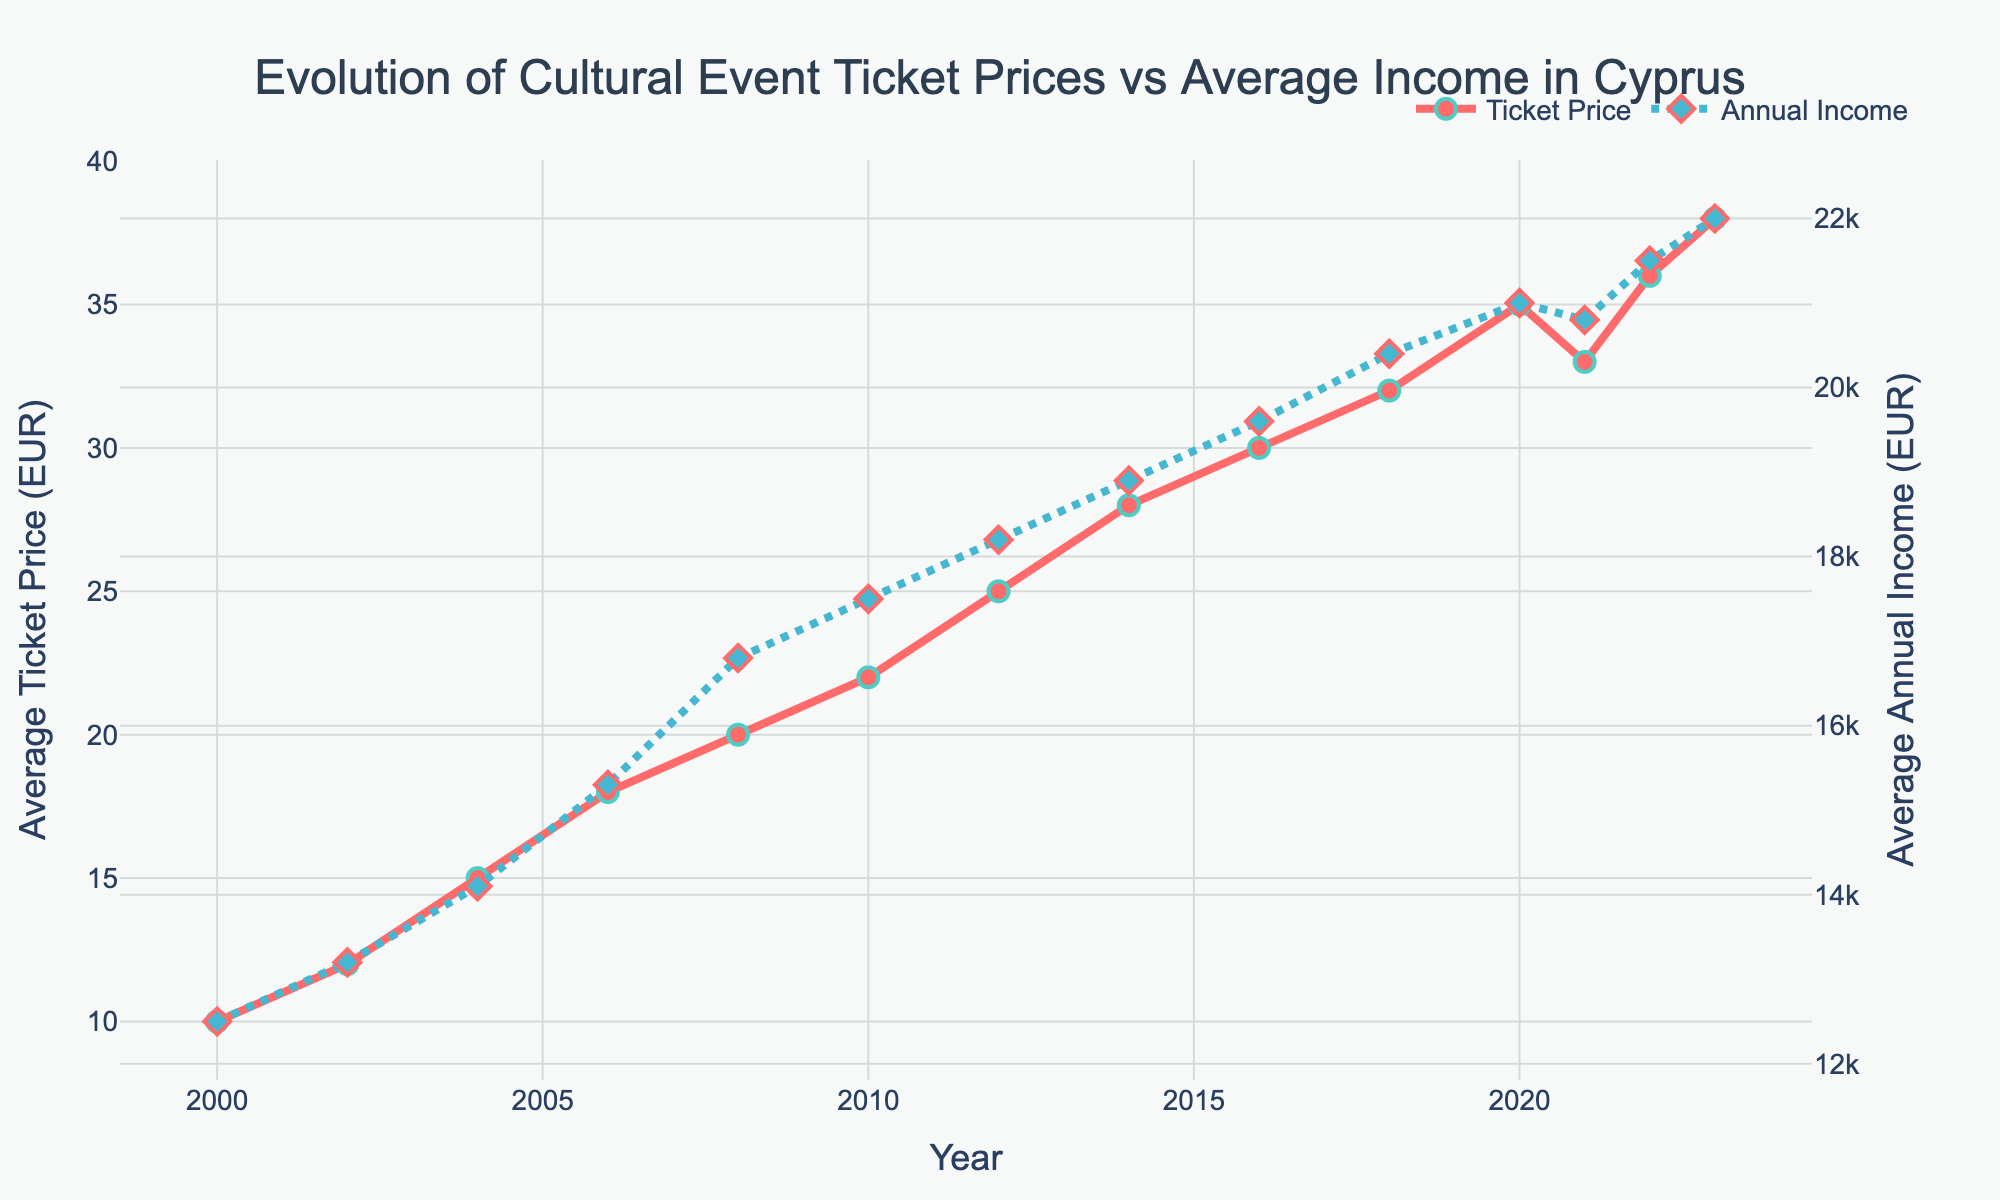What was the average annual income in 2010? To find this, locate the year 2010 on the x-axis and then look at the corresponding value on the secondary y-axis for the blue line representing the average annual income.
Answer: 17500 EUR In which year did the average ticket price increase the most compared to the previous data point? To determine this, examine the difference between consecutive data points on the red line for each interval. The year with the highest increase compared to its immediate predecessor is the one with the largest vertical jump. From 2018 to 2020, the ticket price increased by 3 EUR (35 - 32).
Answer: 2020 What is the difference in average annual income between 2000 and 2023? Find the average annual income values for 2000 and 2023 on the blue line, then subtract the former value from the latter. From the chart, the values are 12500 EUR (2000) and 22000 EUR (2023).
Answer: 9500 EUR During which year did the average ticket price decrease and by how much? To find the year when the average ticket price decreased, look for a downward trend on the red line. This can be observed from 2020 to 2021, where the ticket price dropped from 35 EUR to 33 EUR.
Answer: 2021, 2 EUR Compare the overall trends of average ticket prices and average annual income from 2000 to 2023. Which increased more steeply? Visually comparing the slopes of the red and blue lines from 2000 to 2023, the red line representing ticket prices has a steeper incline compared to the blue line for annual income. This indicates that ticket prices increased more steeply.
Answer: Ticket prices What is the average increase in annual income per year between 2000 and 2023? To find this, calculate the total increase in annual income from 2000 to 2023 and then divide by the number of years (23). The increase is 22000 - 12500 = 9500 EUR, and the average annual increase is 9500 / 23.
Answer: ~413.04 EUR per year By observing the graph, which year had the highest average ticket price? Look for the peak on the red line representing the average ticket price. The highest point is at 38 EUR in 2023.
Answer: 2023 Between which years do you see the smallest increase in both ticket prices and average annual income? Look for intervals where both lines have the least upward movement. This can be observed between 2018 and 2020 for ticket prices and from 2020 to 2021 for annual income.
Answer: 2020 How many times did the average ticket price increase by exactly 2 EUR? Look at the red line and count the intervals where the tick mark increased by exactly 2 EUR. This happened between 2006-2008, 2008-2010, 2016-2018, and 2021-2022.
Answer: 4 times 